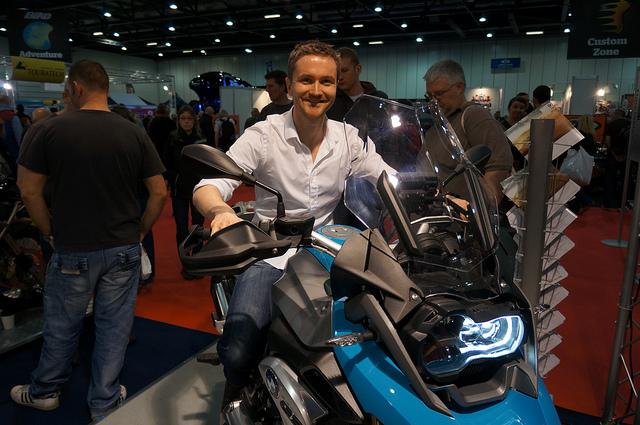What is the man sitting on?
Be succinct. Motorcycle. What color is the motorbike?
Quick response, please. Blue. Is this man going to buy this bike?
Give a very brief answer. No. Is this man having fun?
Write a very short answer. Yes. 